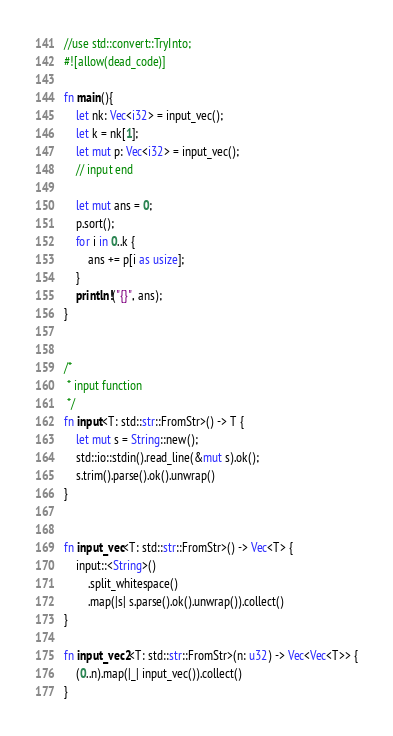<code> <loc_0><loc_0><loc_500><loc_500><_Rust_>//use std::convert::TryInto;
#![allow(dead_code)]

fn main(){
    let nk: Vec<i32> = input_vec();
    let k = nk[1];
    let mut p: Vec<i32> = input_vec();
    // input end

    let mut ans = 0;
    p.sort();
    for i in 0..k {
        ans += p[i as usize];
    }
    println!("{}", ans);
}


/*
 * input function
 */
fn input<T: std::str::FromStr>() -> T {
    let mut s = String::new();
    std::io::stdin().read_line(&mut s).ok();
    s.trim().parse().ok().unwrap()
}


fn input_vec<T: std::str::FromStr>() -> Vec<T> {
    input::<String>()
        .split_whitespace()
        .map(|s| s.parse().ok().unwrap()).collect()
}

fn input_vec2<T: std::str::FromStr>(n: u32) -> Vec<Vec<T>> {
    (0..n).map(|_| input_vec()).collect()
}</code> 